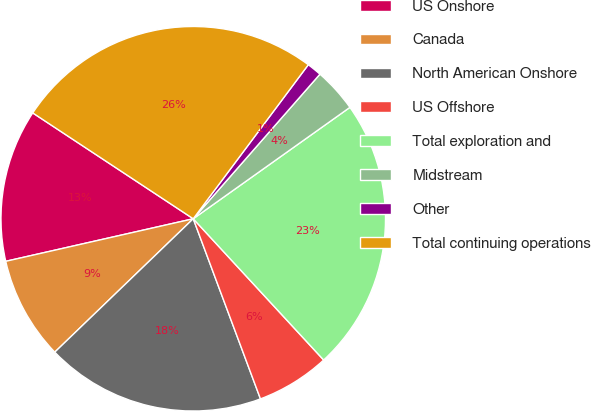<chart> <loc_0><loc_0><loc_500><loc_500><pie_chart><fcel>US Onshore<fcel>Canada<fcel>North American Onshore<fcel>US Offshore<fcel>Total exploration and<fcel>Midstream<fcel>Other<fcel>Total continuing operations<nl><fcel>12.83%<fcel>8.65%<fcel>18.48%<fcel>6.18%<fcel>22.97%<fcel>3.71%<fcel>1.24%<fcel>25.93%<nl></chart> 